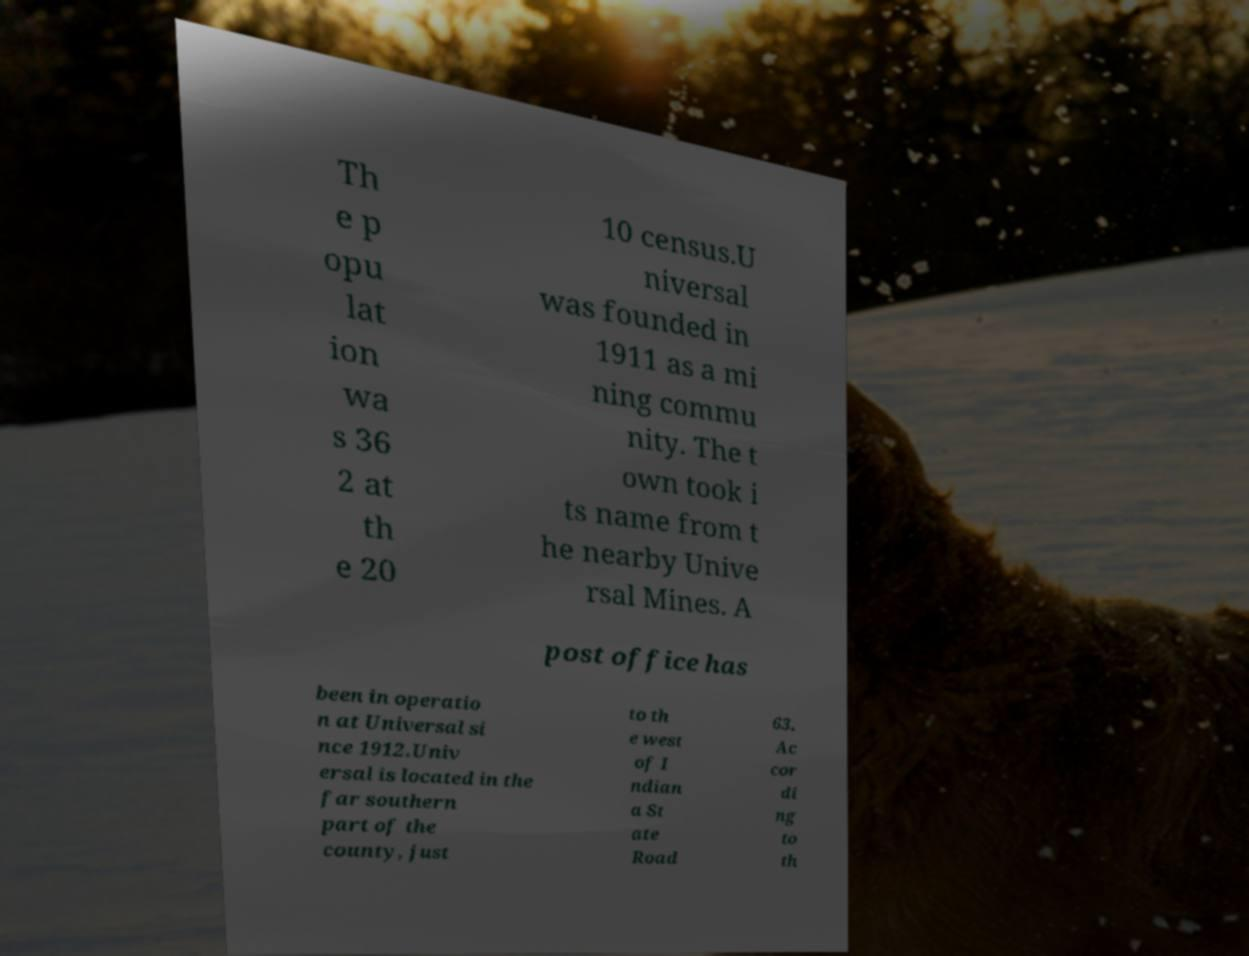There's text embedded in this image that I need extracted. Can you transcribe it verbatim? Th e p opu lat ion wa s 36 2 at th e 20 10 census.U niversal was founded in 1911 as a mi ning commu nity. The t own took i ts name from t he nearby Unive rsal Mines. A post office has been in operatio n at Universal si nce 1912.Univ ersal is located in the far southern part of the county, just to th e west of I ndian a St ate Road 63. Ac cor di ng to th 